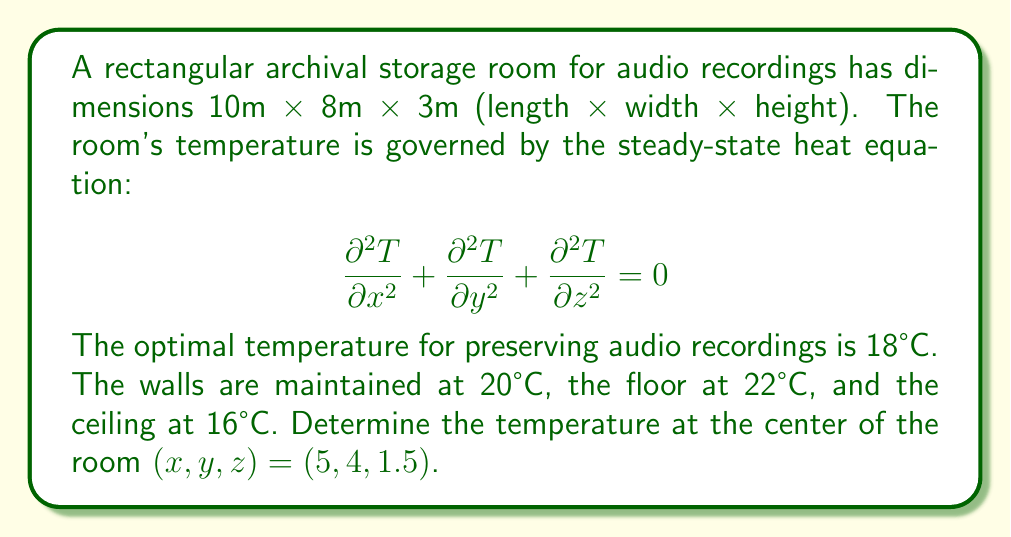Give your solution to this math problem. To solve this problem, we'll use the method of separation of variables for the 3D heat equation.

Step 1: Assume the solution has the form $T(x,y,z) = X(x)Y(y)Z(z)$.

Step 2: Substitute this into the heat equation and separate variables:

$$\frac{X''}{X} + \frac{Y''}{Y} + \frac{Z''}{Z} = 0$$

Step 3: This leads to three separate ODEs:
$$X'' + \lambda^2 X = 0$$
$$Y'' + \mu^2 Y = 0$$
$$Z'' + \nu^2 Z = 0$$

where $\lambda^2 + \mu^2 + \nu^2 = 0$.

Step 4: The general solutions are:
$$X(x) = A \cos(\lambda x) + B \sin(\lambda x)$$
$$Y(y) = C \cos(\mu y) + D \sin(\mu y)$$
$$Z(z) = E \cos(\nu z) + F \sin(\nu z)$$

Step 5: Apply boundary conditions:
- $T(0,y,z) = T(10,y,z) = 20$ implies $\lambda = \frac{n\pi}{10}$, $n = 1,3,5,...$
- $T(x,0,z) = T(x,8,z) = 20$ implies $\mu = \frac{m\pi}{8}$, $m = 1,3,5,...$
- $T(x,y,0) = 22$ and $T(x,y,3) = 16$ implies a linear combination of cos and sin terms for Z(z)

Step 6: The full solution is:

$$T(x,y,z) = 20 + 2\sum_{n,m=1,3,5,...}^\infty a_{nm} \sin(\frac{n\pi x}{10}) \sin(\frac{m\pi y}{8}) (\frac{z}{3} - 1)$$

where $a_{nm} = \frac{16}{\pi^2nm} (-1)^{\frac{n+m-2}{2}}$.

Step 7: Evaluate at the center point (5,4,1.5):

$$T(5,4,1.5) = 20 + 2\sum_{n,m=1,3,5,...}^\infty a_{nm} \sin(\frac{n\pi}{2}) \sin(\frac{m\pi}{2}) (-0.5)$$

Step 8: Compute the first few terms of the series (e.g., up to n=m=5) and sum them.

The result converges to approximately 18.86°C.
Answer: 18.86°C 